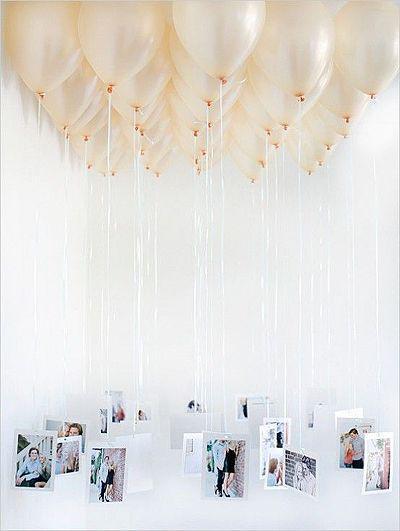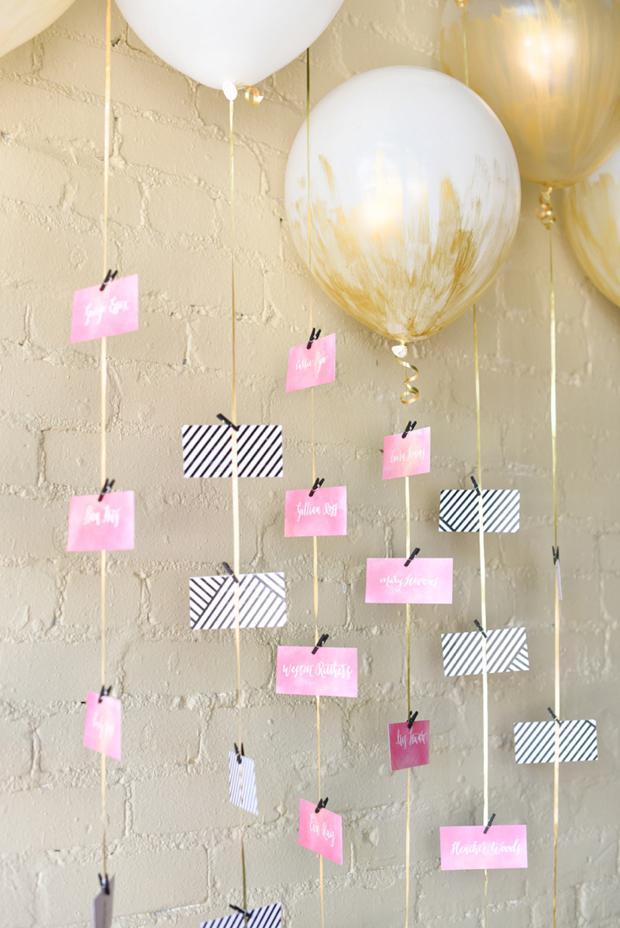The first image is the image on the left, the second image is the image on the right. Given the left and right images, does the statement "There are ornaments hanging down from balloons so clear they are nearly invisible." hold true? Answer yes or no. No. 